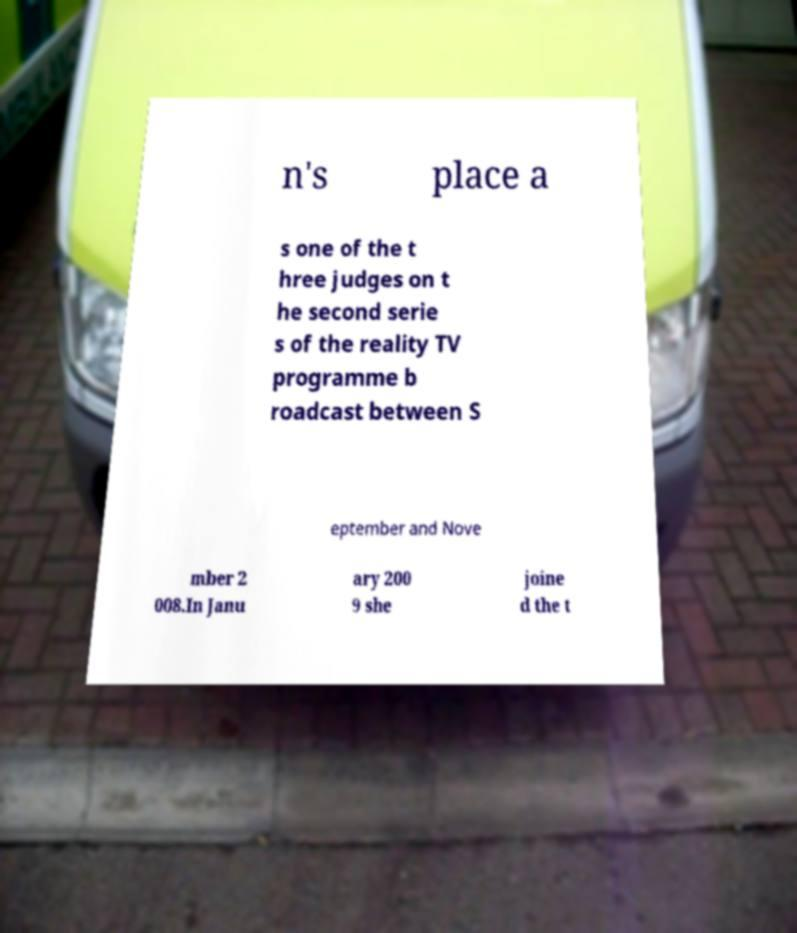What messages or text are displayed in this image? I need them in a readable, typed format. n's place a s one of the t hree judges on t he second serie s of the reality TV programme b roadcast between S eptember and Nove mber 2 008.In Janu ary 200 9 she joine d the t 